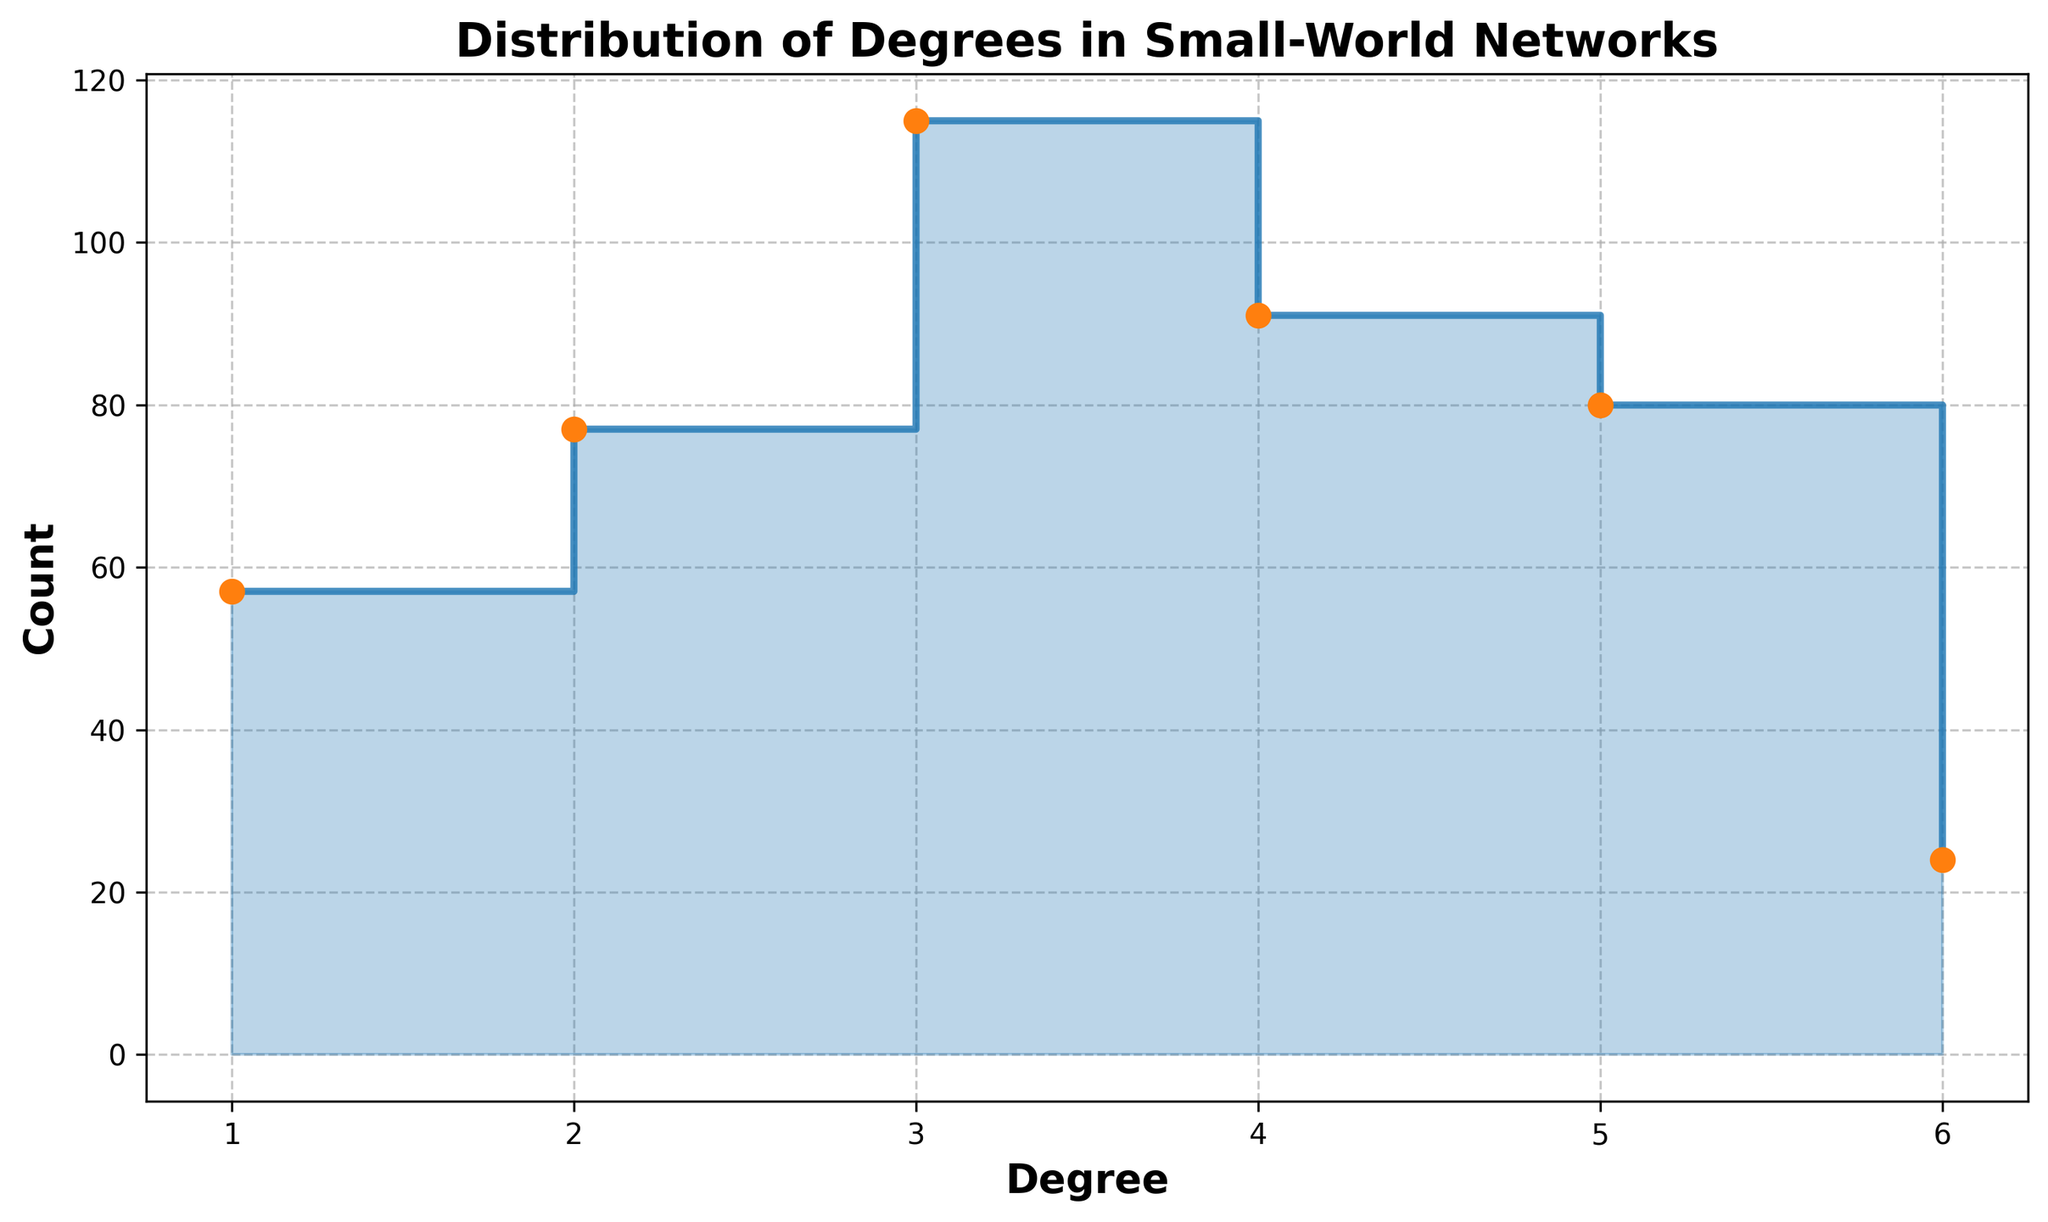What is the title of the plot? The title of the plot is displayed at the top. It reads "Distribution of Degrees in Small-World Networks".
Answer: Distribution of Degrees in Small-World Networks What is the maximum degree shown on the x-axis? The x-axis displays degree values and the last value on the rightmost side is 6.
Answer: 6 What is the label of the y-axis? The y-axis is labeled with the text "Count".
Answer: Count How many unique degree values are represented in the stair plot? The x-axis has tick marks for each unique degree value. By counting these tick marks, we see there are 6 unique degree values (1 through 6).
Answer: 6 Which degree has the highest count? By observing the height of the steps, the highest step corresponds to degree 5.
Answer: 5 What is the sum of counts for degrees 1 and 2? The count for degree 1 is 57 (15 + 12 + 14 + 16), and the count for degree 2 is 77 (25 + 28 + 24). Summing these gives 57 + 77 = 134.
Answer: 134 What is the difference in counts between degrees 3 and 4? The count for degree 3 is 115 (30 + 35 + 22 + 28), and the count for degree 4 is 91 (20 + 25 + 20 + 26). The difference is 115 - 91 = 24.
Answer: 24 Which degrees have a count exactly equal to 14? By looking at the height of the steps and the markers, degree 6 shows a count of 14.
Answer: 6 Is the count for degree 4 greater than or equal to the count for degree 5? Comparing the heights of the corresponding steps, the count for degree 5 (80) is greater than the count for degree 4 (91), so the count for degree 4 is less.
Answer: No What trends can be observed about the distribution of counts across degrees? By analyzing the stair steps, earlier degrees (1 and 2) have lower counts gradually increasing up to degree 5, after which it drops at degree 6.
Answer: Increase up to degree 5 then drops 